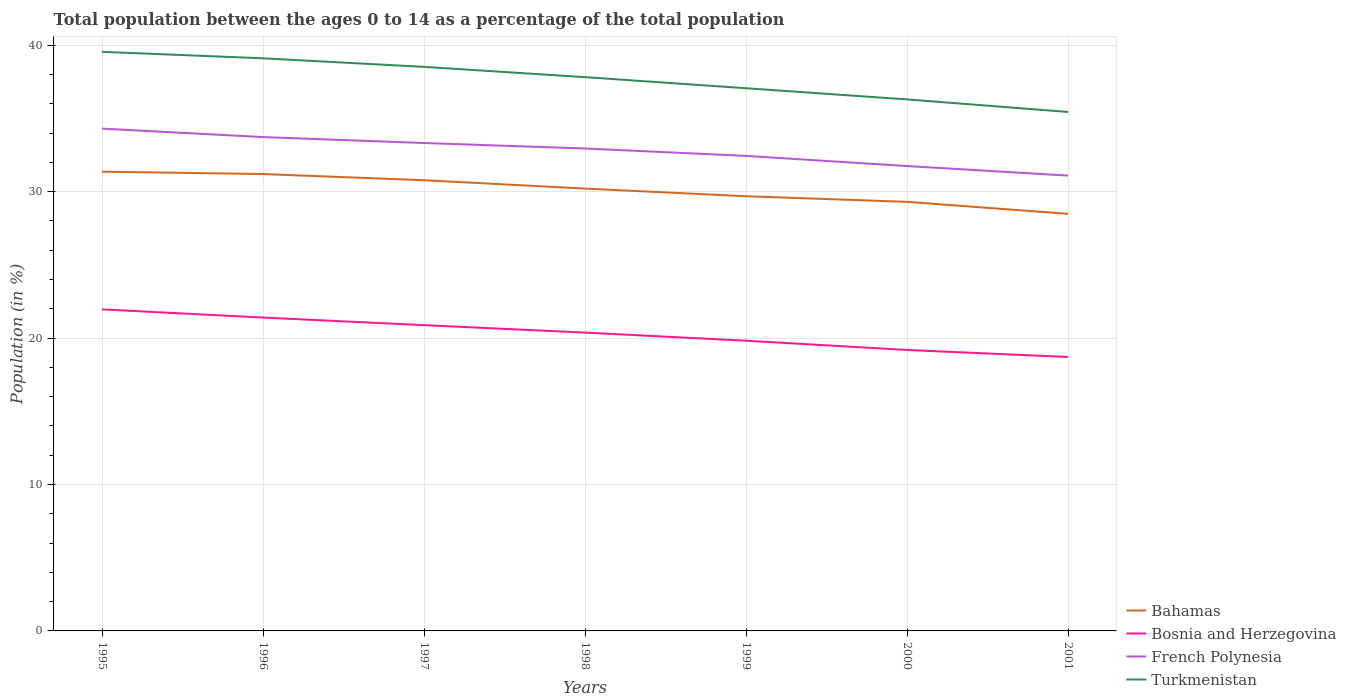How many different coloured lines are there?
Your answer should be compact. 4. Does the line corresponding to French Polynesia intersect with the line corresponding to Bahamas?
Provide a succinct answer. No. Is the number of lines equal to the number of legend labels?
Offer a very short reply. Yes. Across all years, what is the maximum percentage of the population ages 0 to 14 in Bosnia and Herzegovina?
Keep it short and to the point. 18.71. What is the total percentage of the population ages 0 to 14 in Bahamas in the graph?
Give a very brief answer. 0.42. What is the difference between the highest and the second highest percentage of the population ages 0 to 14 in Bosnia and Herzegovina?
Offer a very short reply. 3.25. Is the percentage of the population ages 0 to 14 in Bosnia and Herzegovina strictly greater than the percentage of the population ages 0 to 14 in Bahamas over the years?
Ensure brevity in your answer.  Yes. How many lines are there?
Your response must be concise. 4. How many years are there in the graph?
Provide a succinct answer. 7. What is the difference between two consecutive major ticks on the Y-axis?
Keep it short and to the point. 10. Does the graph contain any zero values?
Offer a terse response. No. Where does the legend appear in the graph?
Provide a short and direct response. Bottom right. How many legend labels are there?
Provide a succinct answer. 4. How are the legend labels stacked?
Keep it short and to the point. Vertical. What is the title of the graph?
Keep it short and to the point. Total population between the ages 0 to 14 as a percentage of the total population. What is the label or title of the Y-axis?
Give a very brief answer. Population (in %). What is the Population (in %) in Bahamas in 1995?
Offer a very short reply. 31.37. What is the Population (in %) of Bosnia and Herzegovina in 1995?
Offer a terse response. 21.96. What is the Population (in %) of French Polynesia in 1995?
Offer a very short reply. 34.31. What is the Population (in %) of Turkmenistan in 1995?
Offer a terse response. 39.55. What is the Population (in %) in Bahamas in 1996?
Give a very brief answer. 31.21. What is the Population (in %) of Bosnia and Herzegovina in 1996?
Your response must be concise. 21.4. What is the Population (in %) of French Polynesia in 1996?
Ensure brevity in your answer.  33.73. What is the Population (in %) in Turkmenistan in 1996?
Give a very brief answer. 39.11. What is the Population (in %) in Bahamas in 1997?
Your response must be concise. 30.78. What is the Population (in %) in Bosnia and Herzegovina in 1997?
Keep it short and to the point. 20.88. What is the Population (in %) in French Polynesia in 1997?
Your answer should be very brief. 33.33. What is the Population (in %) of Turkmenistan in 1997?
Give a very brief answer. 38.53. What is the Population (in %) of Bahamas in 1998?
Offer a terse response. 30.21. What is the Population (in %) in Bosnia and Herzegovina in 1998?
Provide a succinct answer. 20.38. What is the Population (in %) of French Polynesia in 1998?
Make the answer very short. 32.95. What is the Population (in %) of Turkmenistan in 1998?
Your answer should be compact. 37.82. What is the Population (in %) in Bahamas in 1999?
Offer a terse response. 29.69. What is the Population (in %) of Bosnia and Herzegovina in 1999?
Ensure brevity in your answer.  19.82. What is the Population (in %) in French Polynesia in 1999?
Provide a short and direct response. 32.45. What is the Population (in %) in Turkmenistan in 1999?
Keep it short and to the point. 37.07. What is the Population (in %) in Bahamas in 2000?
Give a very brief answer. 29.31. What is the Population (in %) in Bosnia and Herzegovina in 2000?
Provide a short and direct response. 19.19. What is the Population (in %) in French Polynesia in 2000?
Give a very brief answer. 31.75. What is the Population (in %) in Turkmenistan in 2000?
Your answer should be very brief. 36.3. What is the Population (in %) in Bahamas in 2001?
Provide a succinct answer. 28.49. What is the Population (in %) of Bosnia and Herzegovina in 2001?
Provide a short and direct response. 18.71. What is the Population (in %) of French Polynesia in 2001?
Make the answer very short. 31.1. What is the Population (in %) of Turkmenistan in 2001?
Offer a terse response. 35.45. Across all years, what is the maximum Population (in %) in Bahamas?
Your answer should be compact. 31.37. Across all years, what is the maximum Population (in %) of Bosnia and Herzegovina?
Your answer should be compact. 21.96. Across all years, what is the maximum Population (in %) in French Polynesia?
Provide a short and direct response. 34.31. Across all years, what is the maximum Population (in %) of Turkmenistan?
Make the answer very short. 39.55. Across all years, what is the minimum Population (in %) in Bahamas?
Your answer should be compact. 28.49. Across all years, what is the minimum Population (in %) of Bosnia and Herzegovina?
Provide a succinct answer. 18.71. Across all years, what is the minimum Population (in %) of French Polynesia?
Your response must be concise. 31.1. Across all years, what is the minimum Population (in %) of Turkmenistan?
Offer a terse response. 35.45. What is the total Population (in %) in Bahamas in the graph?
Your response must be concise. 211.05. What is the total Population (in %) of Bosnia and Herzegovina in the graph?
Offer a very short reply. 142.35. What is the total Population (in %) of French Polynesia in the graph?
Offer a terse response. 229.62. What is the total Population (in %) in Turkmenistan in the graph?
Offer a terse response. 263.83. What is the difference between the Population (in %) of Bahamas in 1995 and that in 1996?
Your answer should be very brief. 0.16. What is the difference between the Population (in %) of Bosnia and Herzegovina in 1995 and that in 1996?
Provide a succinct answer. 0.56. What is the difference between the Population (in %) in French Polynesia in 1995 and that in 1996?
Your answer should be very brief. 0.58. What is the difference between the Population (in %) in Turkmenistan in 1995 and that in 1996?
Your response must be concise. 0.44. What is the difference between the Population (in %) of Bahamas in 1995 and that in 1997?
Your answer should be compact. 0.59. What is the difference between the Population (in %) of Bosnia and Herzegovina in 1995 and that in 1997?
Your answer should be compact. 1.08. What is the difference between the Population (in %) in French Polynesia in 1995 and that in 1997?
Make the answer very short. 0.98. What is the difference between the Population (in %) in Turkmenistan in 1995 and that in 1997?
Provide a short and direct response. 1.03. What is the difference between the Population (in %) in Bahamas in 1995 and that in 1998?
Provide a short and direct response. 1.16. What is the difference between the Population (in %) of Bosnia and Herzegovina in 1995 and that in 1998?
Your answer should be compact. 1.59. What is the difference between the Population (in %) in French Polynesia in 1995 and that in 1998?
Give a very brief answer. 1.36. What is the difference between the Population (in %) in Turkmenistan in 1995 and that in 1998?
Make the answer very short. 1.73. What is the difference between the Population (in %) of Bahamas in 1995 and that in 1999?
Provide a short and direct response. 1.68. What is the difference between the Population (in %) in Bosnia and Herzegovina in 1995 and that in 1999?
Offer a terse response. 2.14. What is the difference between the Population (in %) in French Polynesia in 1995 and that in 1999?
Offer a very short reply. 1.86. What is the difference between the Population (in %) in Turkmenistan in 1995 and that in 1999?
Offer a terse response. 2.49. What is the difference between the Population (in %) in Bahamas in 1995 and that in 2000?
Make the answer very short. 2.06. What is the difference between the Population (in %) in Bosnia and Herzegovina in 1995 and that in 2000?
Make the answer very short. 2.77. What is the difference between the Population (in %) in French Polynesia in 1995 and that in 2000?
Ensure brevity in your answer.  2.56. What is the difference between the Population (in %) in Turkmenistan in 1995 and that in 2000?
Your answer should be compact. 3.25. What is the difference between the Population (in %) of Bahamas in 1995 and that in 2001?
Make the answer very short. 2.88. What is the difference between the Population (in %) of Bosnia and Herzegovina in 1995 and that in 2001?
Ensure brevity in your answer.  3.25. What is the difference between the Population (in %) in French Polynesia in 1995 and that in 2001?
Provide a succinct answer. 3.21. What is the difference between the Population (in %) of Turkmenistan in 1995 and that in 2001?
Offer a very short reply. 4.11. What is the difference between the Population (in %) in Bahamas in 1996 and that in 1997?
Ensure brevity in your answer.  0.42. What is the difference between the Population (in %) of Bosnia and Herzegovina in 1996 and that in 1997?
Your response must be concise. 0.52. What is the difference between the Population (in %) in French Polynesia in 1996 and that in 1997?
Keep it short and to the point. 0.41. What is the difference between the Population (in %) in Turkmenistan in 1996 and that in 1997?
Offer a very short reply. 0.58. What is the difference between the Population (in %) of Bosnia and Herzegovina in 1996 and that in 1998?
Offer a very short reply. 1.03. What is the difference between the Population (in %) in French Polynesia in 1996 and that in 1998?
Ensure brevity in your answer.  0.78. What is the difference between the Population (in %) in Turkmenistan in 1996 and that in 1998?
Your response must be concise. 1.29. What is the difference between the Population (in %) in Bahamas in 1996 and that in 1999?
Provide a succinct answer. 1.52. What is the difference between the Population (in %) of Bosnia and Herzegovina in 1996 and that in 1999?
Offer a very short reply. 1.58. What is the difference between the Population (in %) in French Polynesia in 1996 and that in 1999?
Provide a succinct answer. 1.29. What is the difference between the Population (in %) of Turkmenistan in 1996 and that in 1999?
Provide a short and direct response. 2.04. What is the difference between the Population (in %) in Bahamas in 1996 and that in 2000?
Ensure brevity in your answer.  1.9. What is the difference between the Population (in %) of Bosnia and Herzegovina in 1996 and that in 2000?
Give a very brief answer. 2.22. What is the difference between the Population (in %) in French Polynesia in 1996 and that in 2000?
Your answer should be very brief. 1.98. What is the difference between the Population (in %) of Turkmenistan in 1996 and that in 2000?
Make the answer very short. 2.81. What is the difference between the Population (in %) in Bahamas in 1996 and that in 2001?
Give a very brief answer. 2.72. What is the difference between the Population (in %) of Bosnia and Herzegovina in 1996 and that in 2001?
Your response must be concise. 2.69. What is the difference between the Population (in %) of French Polynesia in 1996 and that in 2001?
Keep it short and to the point. 2.63. What is the difference between the Population (in %) in Turkmenistan in 1996 and that in 2001?
Your answer should be compact. 3.66. What is the difference between the Population (in %) in Bahamas in 1997 and that in 1998?
Give a very brief answer. 0.57. What is the difference between the Population (in %) in Bosnia and Herzegovina in 1997 and that in 1998?
Your answer should be very brief. 0.51. What is the difference between the Population (in %) of French Polynesia in 1997 and that in 1998?
Your answer should be compact. 0.37. What is the difference between the Population (in %) in Turkmenistan in 1997 and that in 1998?
Provide a succinct answer. 0.7. What is the difference between the Population (in %) of Bahamas in 1997 and that in 1999?
Provide a succinct answer. 1.09. What is the difference between the Population (in %) in Bosnia and Herzegovina in 1997 and that in 1999?
Your answer should be very brief. 1.06. What is the difference between the Population (in %) of French Polynesia in 1997 and that in 1999?
Your answer should be very brief. 0.88. What is the difference between the Population (in %) in Turkmenistan in 1997 and that in 1999?
Your answer should be compact. 1.46. What is the difference between the Population (in %) in Bahamas in 1997 and that in 2000?
Your answer should be compact. 1.48. What is the difference between the Population (in %) in Bosnia and Herzegovina in 1997 and that in 2000?
Give a very brief answer. 1.7. What is the difference between the Population (in %) in French Polynesia in 1997 and that in 2000?
Provide a short and direct response. 1.57. What is the difference between the Population (in %) in Turkmenistan in 1997 and that in 2000?
Your answer should be compact. 2.22. What is the difference between the Population (in %) of Bahamas in 1997 and that in 2001?
Your response must be concise. 2.3. What is the difference between the Population (in %) in Bosnia and Herzegovina in 1997 and that in 2001?
Provide a short and direct response. 2.17. What is the difference between the Population (in %) in French Polynesia in 1997 and that in 2001?
Provide a short and direct response. 2.23. What is the difference between the Population (in %) in Turkmenistan in 1997 and that in 2001?
Provide a succinct answer. 3.08. What is the difference between the Population (in %) of Bahamas in 1998 and that in 1999?
Your response must be concise. 0.52. What is the difference between the Population (in %) in Bosnia and Herzegovina in 1998 and that in 1999?
Ensure brevity in your answer.  0.55. What is the difference between the Population (in %) of French Polynesia in 1998 and that in 1999?
Keep it short and to the point. 0.51. What is the difference between the Population (in %) in Turkmenistan in 1998 and that in 1999?
Your answer should be compact. 0.76. What is the difference between the Population (in %) in Bahamas in 1998 and that in 2000?
Give a very brief answer. 0.91. What is the difference between the Population (in %) of Bosnia and Herzegovina in 1998 and that in 2000?
Ensure brevity in your answer.  1.19. What is the difference between the Population (in %) in French Polynesia in 1998 and that in 2000?
Your response must be concise. 1.2. What is the difference between the Population (in %) of Turkmenistan in 1998 and that in 2000?
Offer a very short reply. 1.52. What is the difference between the Population (in %) of Bahamas in 1998 and that in 2001?
Your answer should be very brief. 1.73. What is the difference between the Population (in %) of Bosnia and Herzegovina in 1998 and that in 2001?
Offer a terse response. 1.67. What is the difference between the Population (in %) of French Polynesia in 1998 and that in 2001?
Provide a short and direct response. 1.85. What is the difference between the Population (in %) of Turkmenistan in 1998 and that in 2001?
Offer a very short reply. 2.38. What is the difference between the Population (in %) in Bahamas in 1999 and that in 2000?
Provide a short and direct response. 0.38. What is the difference between the Population (in %) in Bosnia and Herzegovina in 1999 and that in 2000?
Make the answer very short. 0.63. What is the difference between the Population (in %) of French Polynesia in 1999 and that in 2000?
Your answer should be very brief. 0.69. What is the difference between the Population (in %) in Turkmenistan in 1999 and that in 2000?
Your response must be concise. 0.76. What is the difference between the Population (in %) of Bahamas in 1999 and that in 2001?
Your response must be concise. 1.2. What is the difference between the Population (in %) in Bosnia and Herzegovina in 1999 and that in 2001?
Offer a very short reply. 1.11. What is the difference between the Population (in %) in French Polynesia in 1999 and that in 2001?
Provide a short and direct response. 1.35. What is the difference between the Population (in %) of Turkmenistan in 1999 and that in 2001?
Keep it short and to the point. 1.62. What is the difference between the Population (in %) in Bahamas in 2000 and that in 2001?
Your response must be concise. 0.82. What is the difference between the Population (in %) of Bosnia and Herzegovina in 2000 and that in 2001?
Ensure brevity in your answer.  0.48. What is the difference between the Population (in %) of French Polynesia in 2000 and that in 2001?
Your response must be concise. 0.65. What is the difference between the Population (in %) of Turkmenistan in 2000 and that in 2001?
Your response must be concise. 0.86. What is the difference between the Population (in %) in Bahamas in 1995 and the Population (in %) in Bosnia and Herzegovina in 1996?
Keep it short and to the point. 9.96. What is the difference between the Population (in %) in Bahamas in 1995 and the Population (in %) in French Polynesia in 1996?
Give a very brief answer. -2.36. What is the difference between the Population (in %) in Bahamas in 1995 and the Population (in %) in Turkmenistan in 1996?
Your answer should be compact. -7.74. What is the difference between the Population (in %) in Bosnia and Herzegovina in 1995 and the Population (in %) in French Polynesia in 1996?
Make the answer very short. -11.77. What is the difference between the Population (in %) of Bosnia and Herzegovina in 1995 and the Population (in %) of Turkmenistan in 1996?
Offer a very short reply. -17.15. What is the difference between the Population (in %) of French Polynesia in 1995 and the Population (in %) of Turkmenistan in 1996?
Make the answer very short. -4.8. What is the difference between the Population (in %) in Bahamas in 1995 and the Population (in %) in Bosnia and Herzegovina in 1997?
Provide a succinct answer. 10.48. What is the difference between the Population (in %) of Bahamas in 1995 and the Population (in %) of French Polynesia in 1997?
Keep it short and to the point. -1.96. What is the difference between the Population (in %) in Bahamas in 1995 and the Population (in %) in Turkmenistan in 1997?
Your answer should be very brief. -7.16. What is the difference between the Population (in %) of Bosnia and Herzegovina in 1995 and the Population (in %) of French Polynesia in 1997?
Ensure brevity in your answer.  -11.36. What is the difference between the Population (in %) of Bosnia and Herzegovina in 1995 and the Population (in %) of Turkmenistan in 1997?
Provide a succinct answer. -16.56. What is the difference between the Population (in %) in French Polynesia in 1995 and the Population (in %) in Turkmenistan in 1997?
Your response must be concise. -4.22. What is the difference between the Population (in %) in Bahamas in 1995 and the Population (in %) in Bosnia and Herzegovina in 1998?
Give a very brief answer. 10.99. What is the difference between the Population (in %) in Bahamas in 1995 and the Population (in %) in French Polynesia in 1998?
Offer a terse response. -1.58. What is the difference between the Population (in %) of Bahamas in 1995 and the Population (in %) of Turkmenistan in 1998?
Your response must be concise. -6.46. What is the difference between the Population (in %) of Bosnia and Herzegovina in 1995 and the Population (in %) of French Polynesia in 1998?
Your answer should be compact. -10.99. What is the difference between the Population (in %) in Bosnia and Herzegovina in 1995 and the Population (in %) in Turkmenistan in 1998?
Offer a very short reply. -15.86. What is the difference between the Population (in %) of French Polynesia in 1995 and the Population (in %) of Turkmenistan in 1998?
Provide a succinct answer. -3.52. What is the difference between the Population (in %) of Bahamas in 1995 and the Population (in %) of Bosnia and Herzegovina in 1999?
Make the answer very short. 11.55. What is the difference between the Population (in %) of Bahamas in 1995 and the Population (in %) of French Polynesia in 1999?
Ensure brevity in your answer.  -1.08. What is the difference between the Population (in %) of Bahamas in 1995 and the Population (in %) of Turkmenistan in 1999?
Your answer should be very brief. -5.7. What is the difference between the Population (in %) in Bosnia and Herzegovina in 1995 and the Population (in %) in French Polynesia in 1999?
Give a very brief answer. -10.48. What is the difference between the Population (in %) in Bosnia and Herzegovina in 1995 and the Population (in %) in Turkmenistan in 1999?
Provide a succinct answer. -15.11. What is the difference between the Population (in %) in French Polynesia in 1995 and the Population (in %) in Turkmenistan in 1999?
Offer a terse response. -2.76. What is the difference between the Population (in %) in Bahamas in 1995 and the Population (in %) in Bosnia and Herzegovina in 2000?
Ensure brevity in your answer.  12.18. What is the difference between the Population (in %) in Bahamas in 1995 and the Population (in %) in French Polynesia in 2000?
Make the answer very short. -0.38. What is the difference between the Population (in %) of Bahamas in 1995 and the Population (in %) of Turkmenistan in 2000?
Provide a short and direct response. -4.94. What is the difference between the Population (in %) in Bosnia and Herzegovina in 1995 and the Population (in %) in French Polynesia in 2000?
Make the answer very short. -9.79. What is the difference between the Population (in %) in Bosnia and Herzegovina in 1995 and the Population (in %) in Turkmenistan in 2000?
Your response must be concise. -14.34. What is the difference between the Population (in %) in French Polynesia in 1995 and the Population (in %) in Turkmenistan in 2000?
Your answer should be very brief. -2. What is the difference between the Population (in %) in Bahamas in 1995 and the Population (in %) in Bosnia and Herzegovina in 2001?
Offer a very short reply. 12.66. What is the difference between the Population (in %) in Bahamas in 1995 and the Population (in %) in French Polynesia in 2001?
Your answer should be very brief. 0.27. What is the difference between the Population (in %) of Bahamas in 1995 and the Population (in %) of Turkmenistan in 2001?
Make the answer very short. -4.08. What is the difference between the Population (in %) in Bosnia and Herzegovina in 1995 and the Population (in %) in French Polynesia in 2001?
Your answer should be compact. -9.14. What is the difference between the Population (in %) of Bosnia and Herzegovina in 1995 and the Population (in %) of Turkmenistan in 2001?
Provide a short and direct response. -13.48. What is the difference between the Population (in %) of French Polynesia in 1995 and the Population (in %) of Turkmenistan in 2001?
Make the answer very short. -1.14. What is the difference between the Population (in %) of Bahamas in 1996 and the Population (in %) of Bosnia and Herzegovina in 1997?
Your answer should be compact. 10.32. What is the difference between the Population (in %) of Bahamas in 1996 and the Population (in %) of French Polynesia in 1997?
Your answer should be very brief. -2.12. What is the difference between the Population (in %) of Bahamas in 1996 and the Population (in %) of Turkmenistan in 1997?
Offer a terse response. -7.32. What is the difference between the Population (in %) of Bosnia and Herzegovina in 1996 and the Population (in %) of French Polynesia in 1997?
Make the answer very short. -11.92. What is the difference between the Population (in %) in Bosnia and Herzegovina in 1996 and the Population (in %) in Turkmenistan in 1997?
Provide a short and direct response. -17.12. What is the difference between the Population (in %) of French Polynesia in 1996 and the Population (in %) of Turkmenistan in 1997?
Your answer should be very brief. -4.8. What is the difference between the Population (in %) in Bahamas in 1996 and the Population (in %) in Bosnia and Herzegovina in 1998?
Ensure brevity in your answer.  10.83. What is the difference between the Population (in %) in Bahamas in 1996 and the Population (in %) in French Polynesia in 1998?
Make the answer very short. -1.75. What is the difference between the Population (in %) in Bahamas in 1996 and the Population (in %) in Turkmenistan in 1998?
Your answer should be very brief. -6.62. What is the difference between the Population (in %) in Bosnia and Herzegovina in 1996 and the Population (in %) in French Polynesia in 1998?
Provide a succinct answer. -11.55. What is the difference between the Population (in %) in Bosnia and Herzegovina in 1996 and the Population (in %) in Turkmenistan in 1998?
Offer a terse response. -16.42. What is the difference between the Population (in %) of French Polynesia in 1996 and the Population (in %) of Turkmenistan in 1998?
Provide a short and direct response. -4.09. What is the difference between the Population (in %) of Bahamas in 1996 and the Population (in %) of Bosnia and Herzegovina in 1999?
Ensure brevity in your answer.  11.38. What is the difference between the Population (in %) of Bahamas in 1996 and the Population (in %) of French Polynesia in 1999?
Your response must be concise. -1.24. What is the difference between the Population (in %) of Bahamas in 1996 and the Population (in %) of Turkmenistan in 1999?
Ensure brevity in your answer.  -5.86. What is the difference between the Population (in %) in Bosnia and Herzegovina in 1996 and the Population (in %) in French Polynesia in 1999?
Your answer should be very brief. -11.04. What is the difference between the Population (in %) of Bosnia and Herzegovina in 1996 and the Population (in %) of Turkmenistan in 1999?
Provide a short and direct response. -15.66. What is the difference between the Population (in %) of French Polynesia in 1996 and the Population (in %) of Turkmenistan in 1999?
Keep it short and to the point. -3.34. What is the difference between the Population (in %) of Bahamas in 1996 and the Population (in %) of Bosnia and Herzegovina in 2000?
Provide a succinct answer. 12.02. What is the difference between the Population (in %) in Bahamas in 1996 and the Population (in %) in French Polynesia in 2000?
Your answer should be compact. -0.55. What is the difference between the Population (in %) in Bahamas in 1996 and the Population (in %) in Turkmenistan in 2000?
Your answer should be very brief. -5.1. What is the difference between the Population (in %) in Bosnia and Herzegovina in 1996 and the Population (in %) in French Polynesia in 2000?
Provide a short and direct response. -10.35. What is the difference between the Population (in %) of Bosnia and Herzegovina in 1996 and the Population (in %) of Turkmenistan in 2000?
Offer a very short reply. -14.9. What is the difference between the Population (in %) in French Polynesia in 1996 and the Population (in %) in Turkmenistan in 2000?
Your response must be concise. -2.57. What is the difference between the Population (in %) in Bahamas in 1996 and the Population (in %) in Bosnia and Herzegovina in 2001?
Your response must be concise. 12.5. What is the difference between the Population (in %) in Bahamas in 1996 and the Population (in %) in French Polynesia in 2001?
Make the answer very short. 0.11. What is the difference between the Population (in %) of Bahamas in 1996 and the Population (in %) of Turkmenistan in 2001?
Ensure brevity in your answer.  -4.24. What is the difference between the Population (in %) of Bosnia and Herzegovina in 1996 and the Population (in %) of French Polynesia in 2001?
Your answer should be compact. -9.7. What is the difference between the Population (in %) of Bosnia and Herzegovina in 1996 and the Population (in %) of Turkmenistan in 2001?
Ensure brevity in your answer.  -14.04. What is the difference between the Population (in %) of French Polynesia in 1996 and the Population (in %) of Turkmenistan in 2001?
Provide a short and direct response. -1.72. What is the difference between the Population (in %) in Bahamas in 1997 and the Population (in %) in Bosnia and Herzegovina in 1998?
Offer a very short reply. 10.41. What is the difference between the Population (in %) in Bahamas in 1997 and the Population (in %) in French Polynesia in 1998?
Ensure brevity in your answer.  -2.17. What is the difference between the Population (in %) of Bahamas in 1997 and the Population (in %) of Turkmenistan in 1998?
Provide a short and direct response. -7.04. What is the difference between the Population (in %) of Bosnia and Herzegovina in 1997 and the Population (in %) of French Polynesia in 1998?
Ensure brevity in your answer.  -12.07. What is the difference between the Population (in %) of Bosnia and Herzegovina in 1997 and the Population (in %) of Turkmenistan in 1998?
Give a very brief answer. -16.94. What is the difference between the Population (in %) in French Polynesia in 1997 and the Population (in %) in Turkmenistan in 1998?
Your answer should be very brief. -4.5. What is the difference between the Population (in %) of Bahamas in 1997 and the Population (in %) of Bosnia and Herzegovina in 1999?
Ensure brevity in your answer.  10.96. What is the difference between the Population (in %) in Bahamas in 1997 and the Population (in %) in French Polynesia in 1999?
Provide a succinct answer. -1.66. What is the difference between the Population (in %) in Bahamas in 1997 and the Population (in %) in Turkmenistan in 1999?
Offer a terse response. -6.28. What is the difference between the Population (in %) in Bosnia and Herzegovina in 1997 and the Population (in %) in French Polynesia in 1999?
Provide a succinct answer. -11.56. What is the difference between the Population (in %) of Bosnia and Herzegovina in 1997 and the Population (in %) of Turkmenistan in 1999?
Give a very brief answer. -16.18. What is the difference between the Population (in %) of French Polynesia in 1997 and the Population (in %) of Turkmenistan in 1999?
Give a very brief answer. -3.74. What is the difference between the Population (in %) in Bahamas in 1997 and the Population (in %) in Bosnia and Herzegovina in 2000?
Give a very brief answer. 11.59. What is the difference between the Population (in %) in Bahamas in 1997 and the Population (in %) in French Polynesia in 2000?
Provide a short and direct response. -0.97. What is the difference between the Population (in %) in Bahamas in 1997 and the Population (in %) in Turkmenistan in 2000?
Make the answer very short. -5.52. What is the difference between the Population (in %) in Bosnia and Herzegovina in 1997 and the Population (in %) in French Polynesia in 2000?
Ensure brevity in your answer.  -10.87. What is the difference between the Population (in %) of Bosnia and Herzegovina in 1997 and the Population (in %) of Turkmenistan in 2000?
Offer a very short reply. -15.42. What is the difference between the Population (in %) in French Polynesia in 1997 and the Population (in %) in Turkmenistan in 2000?
Offer a terse response. -2.98. What is the difference between the Population (in %) of Bahamas in 1997 and the Population (in %) of Bosnia and Herzegovina in 2001?
Your answer should be very brief. 12.07. What is the difference between the Population (in %) of Bahamas in 1997 and the Population (in %) of French Polynesia in 2001?
Your answer should be compact. -0.32. What is the difference between the Population (in %) in Bahamas in 1997 and the Population (in %) in Turkmenistan in 2001?
Your answer should be very brief. -4.66. What is the difference between the Population (in %) of Bosnia and Herzegovina in 1997 and the Population (in %) of French Polynesia in 2001?
Offer a very short reply. -10.22. What is the difference between the Population (in %) of Bosnia and Herzegovina in 1997 and the Population (in %) of Turkmenistan in 2001?
Make the answer very short. -14.56. What is the difference between the Population (in %) in French Polynesia in 1997 and the Population (in %) in Turkmenistan in 2001?
Make the answer very short. -2.12. What is the difference between the Population (in %) of Bahamas in 1998 and the Population (in %) of Bosnia and Herzegovina in 1999?
Give a very brief answer. 10.39. What is the difference between the Population (in %) in Bahamas in 1998 and the Population (in %) in French Polynesia in 1999?
Make the answer very short. -2.23. What is the difference between the Population (in %) in Bahamas in 1998 and the Population (in %) in Turkmenistan in 1999?
Provide a short and direct response. -6.85. What is the difference between the Population (in %) of Bosnia and Herzegovina in 1998 and the Population (in %) of French Polynesia in 1999?
Offer a terse response. -12.07. What is the difference between the Population (in %) in Bosnia and Herzegovina in 1998 and the Population (in %) in Turkmenistan in 1999?
Offer a very short reply. -16.69. What is the difference between the Population (in %) of French Polynesia in 1998 and the Population (in %) of Turkmenistan in 1999?
Your answer should be compact. -4.12. What is the difference between the Population (in %) of Bahamas in 1998 and the Population (in %) of Bosnia and Herzegovina in 2000?
Offer a terse response. 11.02. What is the difference between the Population (in %) of Bahamas in 1998 and the Population (in %) of French Polynesia in 2000?
Your response must be concise. -1.54. What is the difference between the Population (in %) of Bahamas in 1998 and the Population (in %) of Turkmenistan in 2000?
Your response must be concise. -6.09. What is the difference between the Population (in %) of Bosnia and Herzegovina in 1998 and the Population (in %) of French Polynesia in 2000?
Provide a short and direct response. -11.38. What is the difference between the Population (in %) in Bosnia and Herzegovina in 1998 and the Population (in %) in Turkmenistan in 2000?
Offer a terse response. -15.93. What is the difference between the Population (in %) in French Polynesia in 1998 and the Population (in %) in Turkmenistan in 2000?
Your response must be concise. -3.35. What is the difference between the Population (in %) of Bahamas in 1998 and the Population (in %) of Bosnia and Herzegovina in 2001?
Make the answer very short. 11.5. What is the difference between the Population (in %) in Bahamas in 1998 and the Population (in %) in French Polynesia in 2001?
Your response must be concise. -0.89. What is the difference between the Population (in %) of Bahamas in 1998 and the Population (in %) of Turkmenistan in 2001?
Your response must be concise. -5.23. What is the difference between the Population (in %) in Bosnia and Herzegovina in 1998 and the Population (in %) in French Polynesia in 2001?
Offer a terse response. -10.72. What is the difference between the Population (in %) in Bosnia and Herzegovina in 1998 and the Population (in %) in Turkmenistan in 2001?
Offer a very short reply. -15.07. What is the difference between the Population (in %) of French Polynesia in 1998 and the Population (in %) of Turkmenistan in 2001?
Your response must be concise. -2.49. What is the difference between the Population (in %) of Bahamas in 1999 and the Population (in %) of Bosnia and Herzegovina in 2000?
Your answer should be very brief. 10.5. What is the difference between the Population (in %) of Bahamas in 1999 and the Population (in %) of French Polynesia in 2000?
Give a very brief answer. -2.06. What is the difference between the Population (in %) in Bahamas in 1999 and the Population (in %) in Turkmenistan in 2000?
Keep it short and to the point. -6.61. What is the difference between the Population (in %) of Bosnia and Herzegovina in 1999 and the Population (in %) of French Polynesia in 2000?
Your answer should be very brief. -11.93. What is the difference between the Population (in %) of Bosnia and Herzegovina in 1999 and the Population (in %) of Turkmenistan in 2000?
Ensure brevity in your answer.  -16.48. What is the difference between the Population (in %) of French Polynesia in 1999 and the Population (in %) of Turkmenistan in 2000?
Provide a short and direct response. -3.86. What is the difference between the Population (in %) in Bahamas in 1999 and the Population (in %) in Bosnia and Herzegovina in 2001?
Offer a very short reply. 10.98. What is the difference between the Population (in %) of Bahamas in 1999 and the Population (in %) of French Polynesia in 2001?
Offer a very short reply. -1.41. What is the difference between the Population (in %) of Bahamas in 1999 and the Population (in %) of Turkmenistan in 2001?
Your answer should be very brief. -5.76. What is the difference between the Population (in %) in Bosnia and Herzegovina in 1999 and the Population (in %) in French Polynesia in 2001?
Ensure brevity in your answer.  -11.28. What is the difference between the Population (in %) in Bosnia and Herzegovina in 1999 and the Population (in %) in Turkmenistan in 2001?
Your response must be concise. -15.62. What is the difference between the Population (in %) in French Polynesia in 1999 and the Population (in %) in Turkmenistan in 2001?
Ensure brevity in your answer.  -3. What is the difference between the Population (in %) of Bahamas in 2000 and the Population (in %) of Bosnia and Herzegovina in 2001?
Offer a terse response. 10.6. What is the difference between the Population (in %) in Bahamas in 2000 and the Population (in %) in French Polynesia in 2001?
Provide a succinct answer. -1.79. What is the difference between the Population (in %) of Bahamas in 2000 and the Population (in %) of Turkmenistan in 2001?
Provide a short and direct response. -6.14. What is the difference between the Population (in %) in Bosnia and Herzegovina in 2000 and the Population (in %) in French Polynesia in 2001?
Provide a succinct answer. -11.91. What is the difference between the Population (in %) in Bosnia and Herzegovina in 2000 and the Population (in %) in Turkmenistan in 2001?
Your answer should be compact. -16.26. What is the difference between the Population (in %) in French Polynesia in 2000 and the Population (in %) in Turkmenistan in 2001?
Provide a short and direct response. -3.69. What is the average Population (in %) of Bahamas per year?
Offer a terse response. 30.15. What is the average Population (in %) in Bosnia and Herzegovina per year?
Your answer should be very brief. 20.34. What is the average Population (in %) in French Polynesia per year?
Provide a short and direct response. 32.8. What is the average Population (in %) in Turkmenistan per year?
Provide a succinct answer. 37.69. In the year 1995, what is the difference between the Population (in %) of Bahamas and Population (in %) of Bosnia and Herzegovina?
Give a very brief answer. 9.41. In the year 1995, what is the difference between the Population (in %) of Bahamas and Population (in %) of French Polynesia?
Give a very brief answer. -2.94. In the year 1995, what is the difference between the Population (in %) of Bahamas and Population (in %) of Turkmenistan?
Keep it short and to the point. -8.18. In the year 1995, what is the difference between the Population (in %) of Bosnia and Herzegovina and Population (in %) of French Polynesia?
Your answer should be very brief. -12.35. In the year 1995, what is the difference between the Population (in %) in Bosnia and Herzegovina and Population (in %) in Turkmenistan?
Give a very brief answer. -17.59. In the year 1995, what is the difference between the Population (in %) in French Polynesia and Population (in %) in Turkmenistan?
Keep it short and to the point. -5.25. In the year 1996, what is the difference between the Population (in %) in Bahamas and Population (in %) in Bosnia and Herzegovina?
Offer a terse response. 9.8. In the year 1996, what is the difference between the Population (in %) of Bahamas and Population (in %) of French Polynesia?
Provide a succinct answer. -2.53. In the year 1996, what is the difference between the Population (in %) in Bahamas and Population (in %) in Turkmenistan?
Offer a very short reply. -7.91. In the year 1996, what is the difference between the Population (in %) in Bosnia and Herzegovina and Population (in %) in French Polynesia?
Offer a terse response. -12.33. In the year 1996, what is the difference between the Population (in %) of Bosnia and Herzegovina and Population (in %) of Turkmenistan?
Give a very brief answer. -17.71. In the year 1996, what is the difference between the Population (in %) of French Polynesia and Population (in %) of Turkmenistan?
Keep it short and to the point. -5.38. In the year 1997, what is the difference between the Population (in %) in Bahamas and Population (in %) in Bosnia and Herzegovina?
Give a very brief answer. 9.9. In the year 1997, what is the difference between the Population (in %) in Bahamas and Population (in %) in French Polynesia?
Provide a short and direct response. -2.54. In the year 1997, what is the difference between the Population (in %) in Bahamas and Population (in %) in Turkmenistan?
Provide a succinct answer. -7.74. In the year 1997, what is the difference between the Population (in %) of Bosnia and Herzegovina and Population (in %) of French Polynesia?
Provide a succinct answer. -12.44. In the year 1997, what is the difference between the Population (in %) of Bosnia and Herzegovina and Population (in %) of Turkmenistan?
Provide a short and direct response. -17.64. In the year 1997, what is the difference between the Population (in %) in French Polynesia and Population (in %) in Turkmenistan?
Offer a terse response. -5.2. In the year 1998, what is the difference between the Population (in %) of Bahamas and Population (in %) of Bosnia and Herzegovina?
Your answer should be very brief. 9.84. In the year 1998, what is the difference between the Population (in %) in Bahamas and Population (in %) in French Polynesia?
Offer a terse response. -2.74. In the year 1998, what is the difference between the Population (in %) of Bahamas and Population (in %) of Turkmenistan?
Your answer should be very brief. -7.61. In the year 1998, what is the difference between the Population (in %) in Bosnia and Herzegovina and Population (in %) in French Polynesia?
Provide a succinct answer. -12.58. In the year 1998, what is the difference between the Population (in %) of Bosnia and Herzegovina and Population (in %) of Turkmenistan?
Your answer should be compact. -17.45. In the year 1998, what is the difference between the Population (in %) of French Polynesia and Population (in %) of Turkmenistan?
Ensure brevity in your answer.  -4.87. In the year 1999, what is the difference between the Population (in %) in Bahamas and Population (in %) in Bosnia and Herzegovina?
Your response must be concise. 9.87. In the year 1999, what is the difference between the Population (in %) of Bahamas and Population (in %) of French Polynesia?
Give a very brief answer. -2.76. In the year 1999, what is the difference between the Population (in %) in Bahamas and Population (in %) in Turkmenistan?
Provide a short and direct response. -7.38. In the year 1999, what is the difference between the Population (in %) in Bosnia and Herzegovina and Population (in %) in French Polynesia?
Provide a short and direct response. -12.62. In the year 1999, what is the difference between the Population (in %) in Bosnia and Herzegovina and Population (in %) in Turkmenistan?
Your response must be concise. -17.25. In the year 1999, what is the difference between the Population (in %) in French Polynesia and Population (in %) in Turkmenistan?
Provide a succinct answer. -4.62. In the year 2000, what is the difference between the Population (in %) of Bahamas and Population (in %) of Bosnia and Herzegovina?
Keep it short and to the point. 10.12. In the year 2000, what is the difference between the Population (in %) of Bahamas and Population (in %) of French Polynesia?
Ensure brevity in your answer.  -2.45. In the year 2000, what is the difference between the Population (in %) of Bahamas and Population (in %) of Turkmenistan?
Provide a succinct answer. -7. In the year 2000, what is the difference between the Population (in %) of Bosnia and Herzegovina and Population (in %) of French Polynesia?
Make the answer very short. -12.56. In the year 2000, what is the difference between the Population (in %) of Bosnia and Herzegovina and Population (in %) of Turkmenistan?
Give a very brief answer. -17.12. In the year 2000, what is the difference between the Population (in %) in French Polynesia and Population (in %) in Turkmenistan?
Your answer should be compact. -4.55. In the year 2001, what is the difference between the Population (in %) of Bahamas and Population (in %) of Bosnia and Herzegovina?
Offer a terse response. 9.78. In the year 2001, what is the difference between the Population (in %) in Bahamas and Population (in %) in French Polynesia?
Your answer should be very brief. -2.61. In the year 2001, what is the difference between the Population (in %) of Bahamas and Population (in %) of Turkmenistan?
Give a very brief answer. -6.96. In the year 2001, what is the difference between the Population (in %) of Bosnia and Herzegovina and Population (in %) of French Polynesia?
Your response must be concise. -12.39. In the year 2001, what is the difference between the Population (in %) of Bosnia and Herzegovina and Population (in %) of Turkmenistan?
Offer a very short reply. -16.74. In the year 2001, what is the difference between the Population (in %) of French Polynesia and Population (in %) of Turkmenistan?
Keep it short and to the point. -4.35. What is the ratio of the Population (in %) of Bahamas in 1995 to that in 1996?
Ensure brevity in your answer.  1.01. What is the ratio of the Population (in %) in Bosnia and Herzegovina in 1995 to that in 1996?
Your response must be concise. 1.03. What is the ratio of the Population (in %) of French Polynesia in 1995 to that in 1996?
Offer a terse response. 1.02. What is the ratio of the Population (in %) in Turkmenistan in 1995 to that in 1996?
Provide a succinct answer. 1.01. What is the ratio of the Population (in %) in Bahamas in 1995 to that in 1997?
Your response must be concise. 1.02. What is the ratio of the Population (in %) in Bosnia and Herzegovina in 1995 to that in 1997?
Your answer should be very brief. 1.05. What is the ratio of the Population (in %) of French Polynesia in 1995 to that in 1997?
Your response must be concise. 1.03. What is the ratio of the Population (in %) of Turkmenistan in 1995 to that in 1997?
Provide a succinct answer. 1.03. What is the ratio of the Population (in %) in Bahamas in 1995 to that in 1998?
Offer a terse response. 1.04. What is the ratio of the Population (in %) of Bosnia and Herzegovina in 1995 to that in 1998?
Offer a very short reply. 1.08. What is the ratio of the Population (in %) in French Polynesia in 1995 to that in 1998?
Offer a terse response. 1.04. What is the ratio of the Population (in %) in Turkmenistan in 1995 to that in 1998?
Your answer should be very brief. 1.05. What is the ratio of the Population (in %) of Bahamas in 1995 to that in 1999?
Make the answer very short. 1.06. What is the ratio of the Population (in %) of Bosnia and Herzegovina in 1995 to that in 1999?
Your answer should be very brief. 1.11. What is the ratio of the Population (in %) of French Polynesia in 1995 to that in 1999?
Provide a short and direct response. 1.06. What is the ratio of the Population (in %) in Turkmenistan in 1995 to that in 1999?
Your answer should be very brief. 1.07. What is the ratio of the Population (in %) of Bahamas in 1995 to that in 2000?
Your answer should be compact. 1.07. What is the ratio of the Population (in %) in Bosnia and Herzegovina in 1995 to that in 2000?
Offer a terse response. 1.14. What is the ratio of the Population (in %) in French Polynesia in 1995 to that in 2000?
Offer a terse response. 1.08. What is the ratio of the Population (in %) of Turkmenistan in 1995 to that in 2000?
Offer a very short reply. 1.09. What is the ratio of the Population (in %) in Bahamas in 1995 to that in 2001?
Provide a short and direct response. 1.1. What is the ratio of the Population (in %) of Bosnia and Herzegovina in 1995 to that in 2001?
Give a very brief answer. 1.17. What is the ratio of the Population (in %) in French Polynesia in 1995 to that in 2001?
Make the answer very short. 1.1. What is the ratio of the Population (in %) in Turkmenistan in 1995 to that in 2001?
Ensure brevity in your answer.  1.12. What is the ratio of the Population (in %) in Bahamas in 1996 to that in 1997?
Your response must be concise. 1.01. What is the ratio of the Population (in %) of Bosnia and Herzegovina in 1996 to that in 1997?
Keep it short and to the point. 1.02. What is the ratio of the Population (in %) of French Polynesia in 1996 to that in 1997?
Offer a very short reply. 1.01. What is the ratio of the Population (in %) of Turkmenistan in 1996 to that in 1997?
Your answer should be compact. 1.02. What is the ratio of the Population (in %) in Bahamas in 1996 to that in 1998?
Ensure brevity in your answer.  1.03. What is the ratio of the Population (in %) in Bosnia and Herzegovina in 1996 to that in 1998?
Your answer should be compact. 1.05. What is the ratio of the Population (in %) of French Polynesia in 1996 to that in 1998?
Offer a very short reply. 1.02. What is the ratio of the Population (in %) of Turkmenistan in 1996 to that in 1998?
Offer a very short reply. 1.03. What is the ratio of the Population (in %) of Bahamas in 1996 to that in 1999?
Make the answer very short. 1.05. What is the ratio of the Population (in %) of Bosnia and Herzegovina in 1996 to that in 1999?
Offer a very short reply. 1.08. What is the ratio of the Population (in %) in French Polynesia in 1996 to that in 1999?
Make the answer very short. 1.04. What is the ratio of the Population (in %) in Turkmenistan in 1996 to that in 1999?
Provide a short and direct response. 1.06. What is the ratio of the Population (in %) in Bahamas in 1996 to that in 2000?
Offer a very short reply. 1.06. What is the ratio of the Population (in %) of Bosnia and Herzegovina in 1996 to that in 2000?
Keep it short and to the point. 1.12. What is the ratio of the Population (in %) in French Polynesia in 1996 to that in 2000?
Your answer should be compact. 1.06. What is the ratio of the Population (in %) of Turkmenistan in 1996 to that in 2000?
Provide a short and direct response. 1.08. What is the ratio of the Population (in %) of Bahamas in 1996 to that in 2001?
Provide a short and direct response. 1.1. What is the ratio of the Population (in %) in Bosnia and Herzegovina in 1996 to that in 2001?
Provide a short and direct response. 1.14. What is the ratio of the Population (in %) in French Polynesia in 1996 to that in 2001?
Your response must be concise. 1.08. What is the ratio of the Population (in %) of Turkmenistan in 1996 to that in 2001?
Provide a short and direct response. 1.1. What is the ratio of the Population (in %) of Bahamas in 1997 to that in 1998?
Offer a terse response. 1.02. What is the ratio of the Population (in %) of Bosnia and Herzegovina in 1997 to that in 1998?
Ensure brevity in your answer.  1.02. What is the ratio of the Population (in %) in French Polynesia in 1997 to that in 1998?
Offer a terse response. 1.01. What is the ratio of the Population (in %) of Turkmenistan in 1997 to that in 1998?
Provide a short and direct response. 1.02. What is the ratio of the Population (in %) in Bahamas in 1997 to that in 1999?
Provide a short and direct response. 1.04. What is the ratio of the Population (in %) of Bosnia and Herzegovina in 1997 to that in 1999?
Ensure brevity in your answer.  1.05. What is the ratio of the Population (in %) of French Polynesia in 1997 to that in 1999?
Your response must be concise. 1.03. What is the ratio of the Population (in %) in Turkmenistan in 1997 to that in 1999?
Offer a very short reply. 1.04. What is the ratio of the Population (in %) in Bahamas in 1997 to that in 2000?
Your response must be concise. 1.05. What is the ratio of the Population (in %) in Bosnia and Herzegovina in 1997 to that in 2000?
Keep it short and to the point. 1.09. What is the ratio of the Population (in %) of French Polynesia in 1997 to that in 2000?
Offer a terse response. 1.05. What is the ratio of the Population (in %) of Turkmenistan in 1997 to that in 2000?
Offer a terse response. 1.06. What is the ratio of the Population (in %) of Bahamas in 1997 to that in 2001?
Offer a terse response. 1.08. What is the ratio of the Population (in %) in Bosnia and Herzegovina in 1997 to that in 2001?
Your answer should be compact. 1.12. What is the ratio of the Population (in %) of French Polynesia in 1997 to that in 2001?
Your answer should be very brief. 1.07. What is the ratio of the Population (in %) in Turkmenistan in 1997 to that in 2001?
Your answer should be compact. 1.09. What is the ratio of the Population (in %) of Bahamas in 1998 to that in 1999?
Give a very brief answer. 1.02. What is the ratio of the Population (in %) of Bosnia and Herzegovina in 1998 to that in 1999?
Keep it short and to the point. 1.03. What is the ratio of the Population (in %) in French Polynesia in 1998 to that in 1999?
Keep it short and to the point. 1.02. What is the ratio of the Population (in %) of Turkmenistan in 1998 to that in 1999?
Give a very brief answer. 1.02. What is the ratio of the Population (in %) of Bahamas in 1998 to that in 2000?
Keep it short and to the point. 1.03. What is the ratio of the Population (in %) of Bosnia and Herzegovina in 1998 to that in 2000?
Your answer should be very brief. 1.06. What is the ratio of the Population (in %) of French Polynesia in 1998 to that in 2000?
Your answer should be very brief. 1.04. What is the ratio of the Population (in %) of Turkmenistan in 1998 to that in 2000?
Make the answer very short. 1.04. What is the ratio of the Population (in %) in Bahamas in 1998 to that in 2001?
Provide a short and direct response. 1.06. What is the ratio of the Population (in %) of Bosnia and Herzegovina in 1998 to that in 2001?
Give a very brief answer. 1.09. What is the ratio of the Population (in %) in French Polynesia in 1998 to that in 2001?
Ensure brevity in your answer.  1.06. What is the ratio of the Population (in %) in Turkmenistan in 1998 to that in 2001?
Your response must be concise. 1.07. What is the ratio of the Population (in %) in Bahamas in 1999 to that in 2000?
Give a very brief answer. 1.01. What is the ratio of the Population (in %) of Bosnia and Herzegovina in 1999 to that in 2000?
Provide a short and direct response. 1.03. What is the ratio of the Population (in %) of French Polynesia in 1999 to that in 2000?
Provide a short and direct response. 1.02. What is the ratio of the Population (in %) in Bahamas in 1999 to that in 2001?
Offer a terse response. 1.04. What is the ratio of the Population (in %) of Bosnia and Herzegovina in 1999 to that in 2001?
Make the answer very short. 1.06. What is the ratio of the Population (in %) in French Polynesia in 1999 to that in 2001?
Provide a short and direct response. 1.04. What is the ratio of the Population (in %) of Turkmenistan in 1999 to that in 2001?
Your answer should be compact. 1.05. What is the ratio of the Population (in %) of Bahamas in 2000 to that in 2001?
Your answer should be very brief. 1.03. What is the ratio of the Population (in %) in Bosnia and Herzegovina in 2000 to that in 2001?
Make the answer very short. 1.03. What is the ratio of the Population (in %) in French Polynesia in 2000 to that in 2001?
Give a very brief answer. 1.02. What is the ratio of the Population (in %) of Turkmenistan in 2000 to that in 2001?
Give a very brief answer. 1.02. What is the difference between the highest and the second highest Population (in %) of Bahamas?
Keep it short and to the point. 0.16. What is the difference between the highest and the second highest Population (in %) of Bosnia and Herzegovina?
Your answer should be very brief. 0.56. What is the difference between the highest and the second highest Population (in %) of French Polynesia?
Keep it short and to the point. 0.58. What is the difference between the highest and the second highest Population (in %) of Turkmenistan?
Provide a short and direct response. 0.44. What is the difference between the highest and the lowest Population (in %) in Bahamas?
Offer a very short reply. 2.88. What is the difference between the highest and the lowest Population (in %) of Bosnia and Herzegovina?
Your answer should be compact. 3.25. What is the difference between the highest and the lowest Population (in %) in French Polynesia?
Provide a short and direct response. 3.21. What is the difference between the highest and the lowest Population (in %) in Turkmenistan?
Your response must be concise. 4.11. 